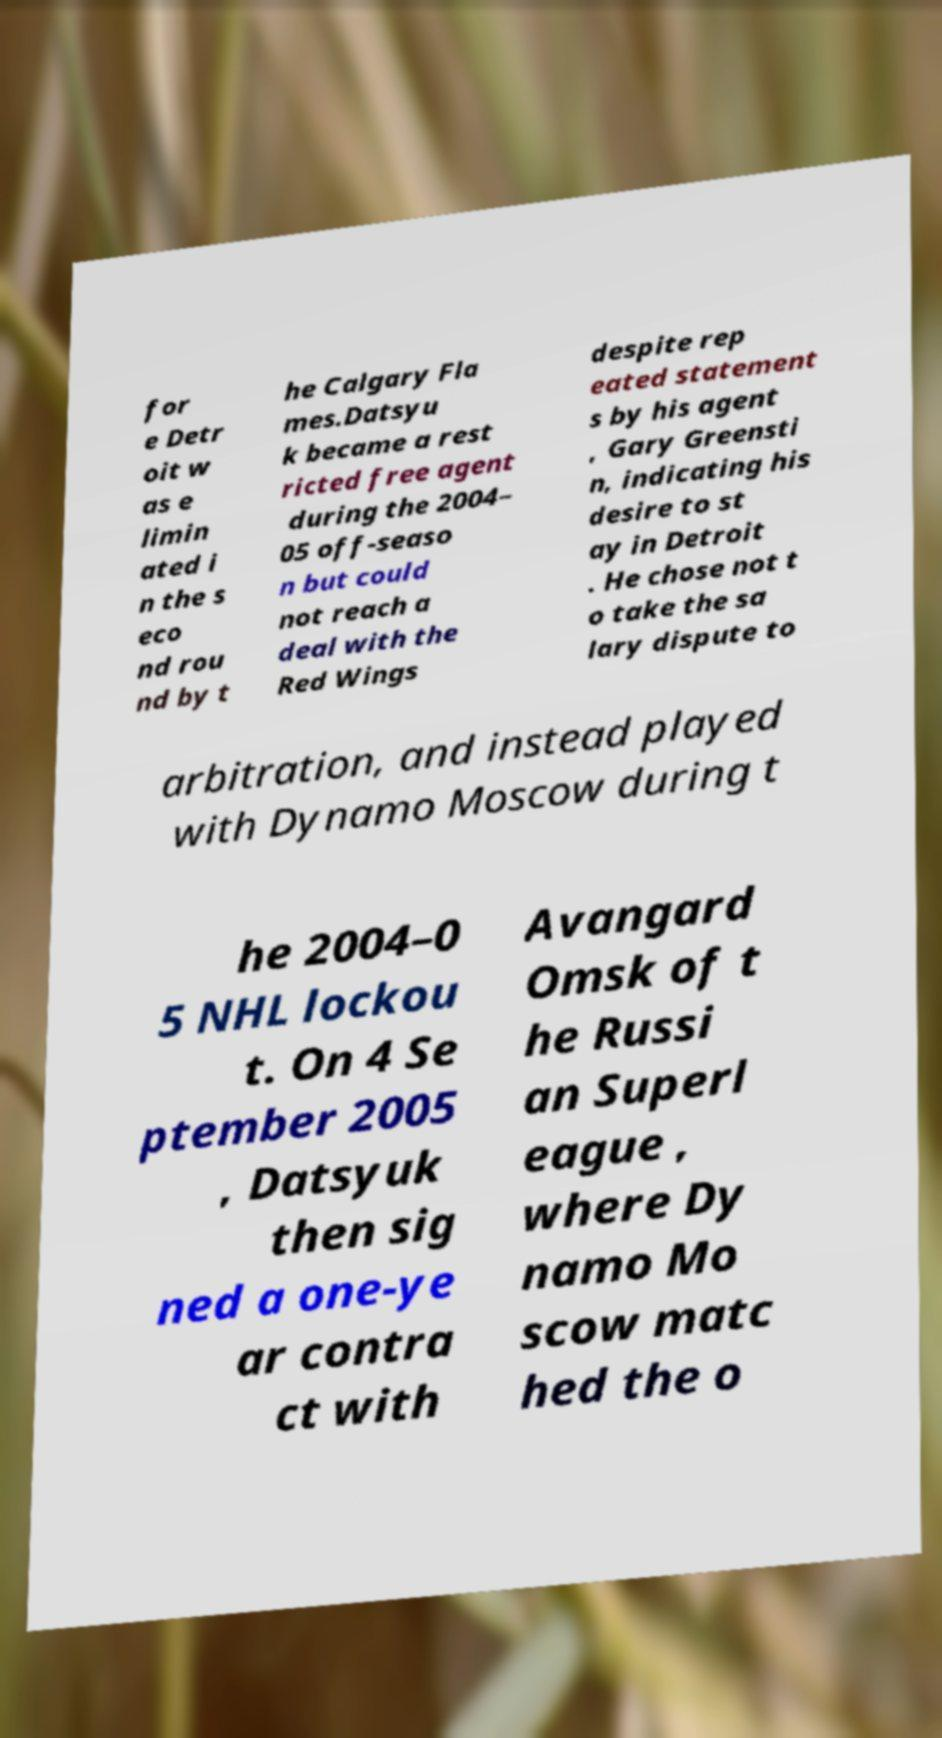Can you accurately transcribe the text from the provided image for me? for e Detr oit w as e limin ated i n the s eco nd rou nd by t he Calgary Fla mes.Datsyu k became a rest ricted free agent during the 2004– 05 off-seaso n but could not reach a deal with the Red Wings despite rep eated statement s by his agent , Gary Greensti n, indicating his desire to st ay in Detroit . He chose not t o take the sa lary dispute to arbitration, and instead played with Dynamo Moscow during t he 2004–0 5 NHL lockou t. On 4 Se ptember 2005 , Datsyuk then sig ned a one-ye ar contra ct with Avangard Omsk of t he Russi an Superl eague , where Dy namo Mo scow matc hed the o 